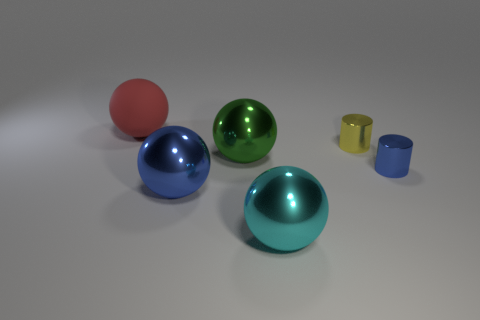Is there anything else that has the same material as the red object?
Provide a short and direct response. No. How many tiny yellow spheres are there?
Keep it short and to the point. 0. There is a red matte thing; does it have the same shape as the tiny metallic thing that is on the left side of the blue cylinder?
Give a very brief answer. No. How many objects are large green metal spheres or shiny spheres behind the large blue metallic ball?
Offer a terse response. 1. What material is the blue object that is the same shape as the red thing?
Provide a succinct answer. Metal. Do the blue thing that is left of the tiny blue metallic thing and the red object have the same shape?
Your answer should be compact. Yes. Is the number of big cyan metallic things that are behind the matte object less than the number of shiny objects that are on the left side of the large green metal sphere?
Offer a very short reply. Yes. What number of other objects are the same shape as the red rubber object?
Offer a very short reply. 3. What is the size of the metallic ball that is left of the green metallic thing left of the small object that is to the right of the yellow metallic thing?
Your answer should be very brief. Large. How many blue things are spheres or matte things?
Your response must be concise. 1. 